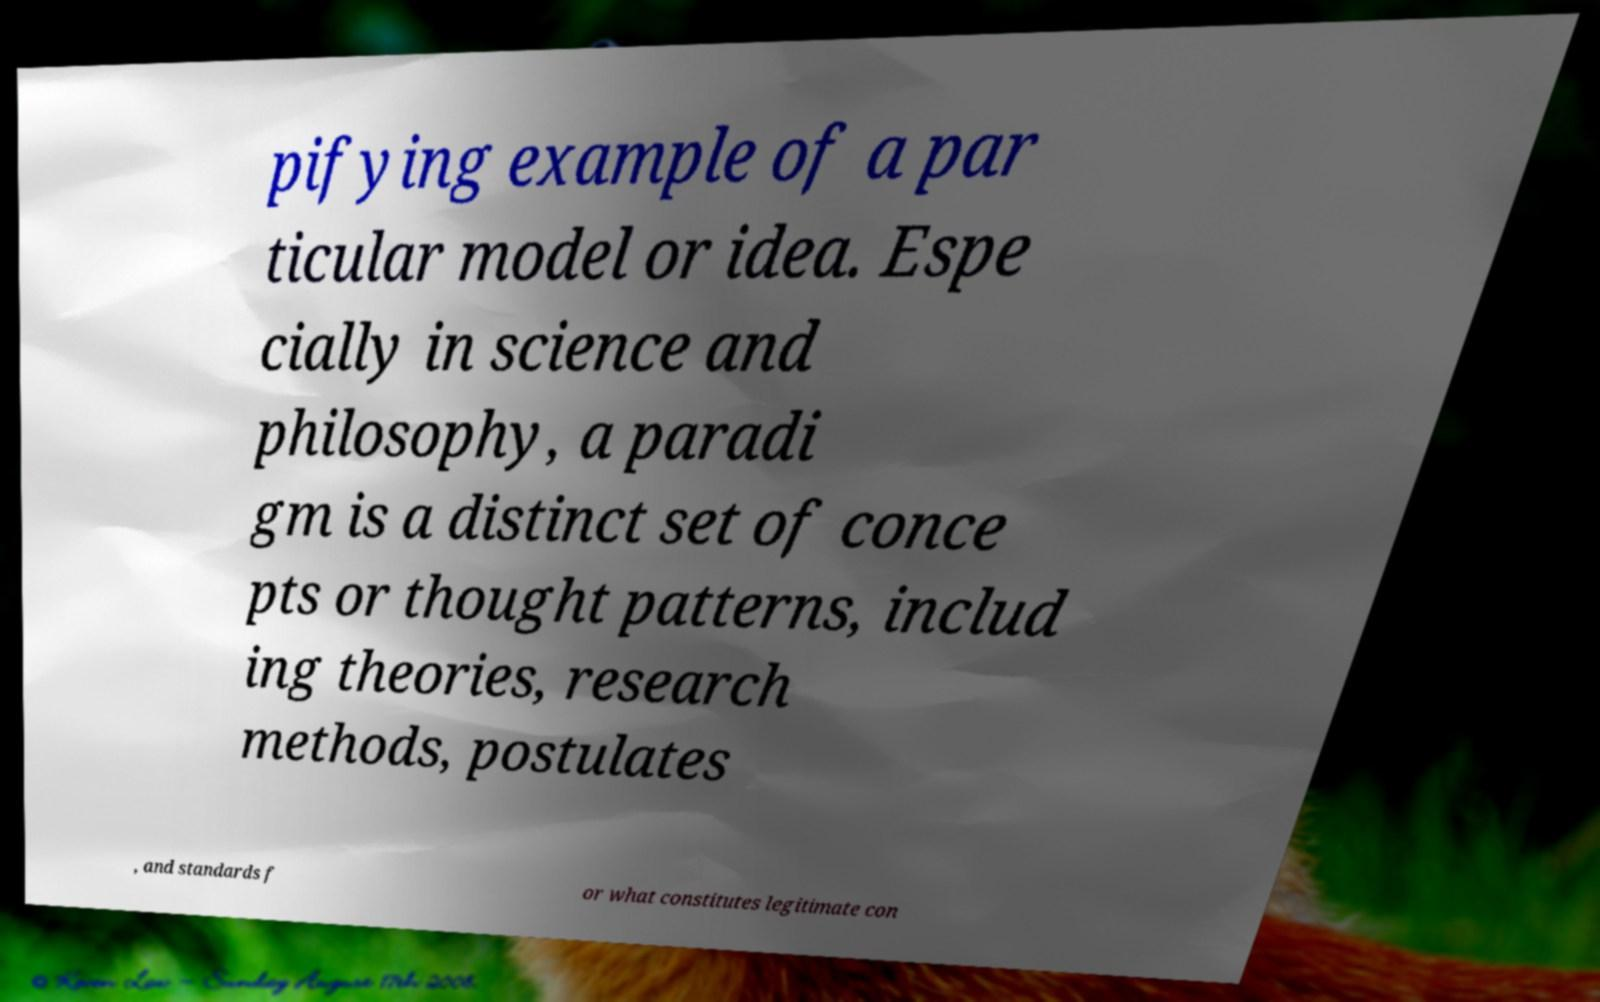There's text embedded in this image that I need extracted. Can you transcribe it verbatim? pifying example of a par ticular model or idea. Espe cially in science and philosophy, a paradi gm is a distinct set of conce pts or thought patterns, includ ing theories, research methods, postulates , and standards f or what constitutes legitimate con 